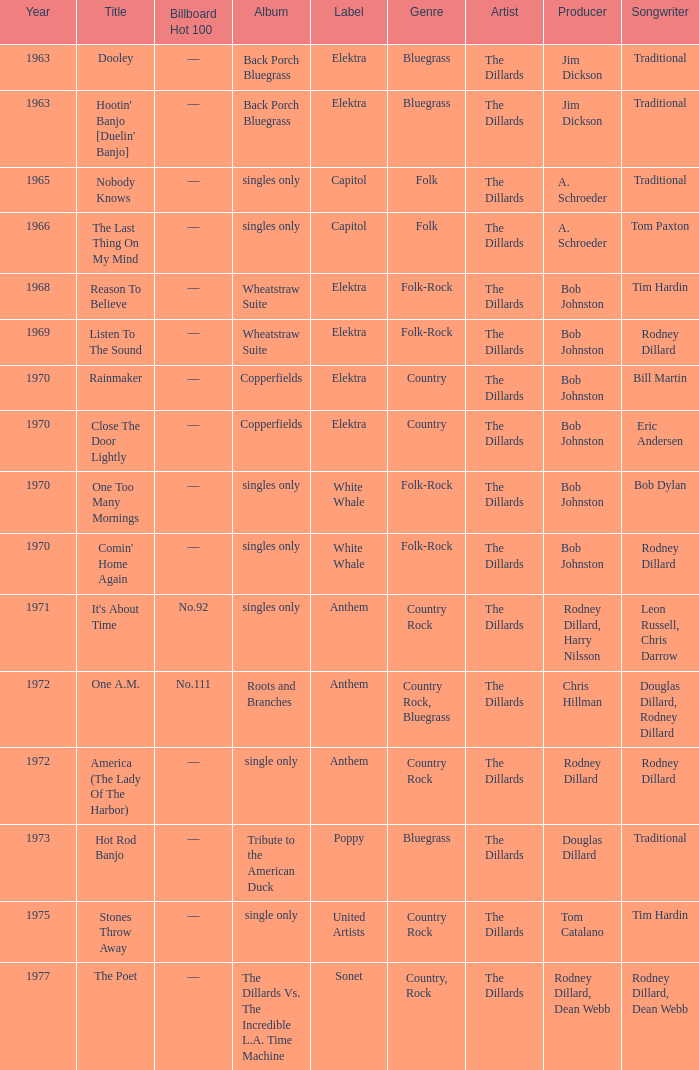What is the total years for roots and branches? 1972.0. 